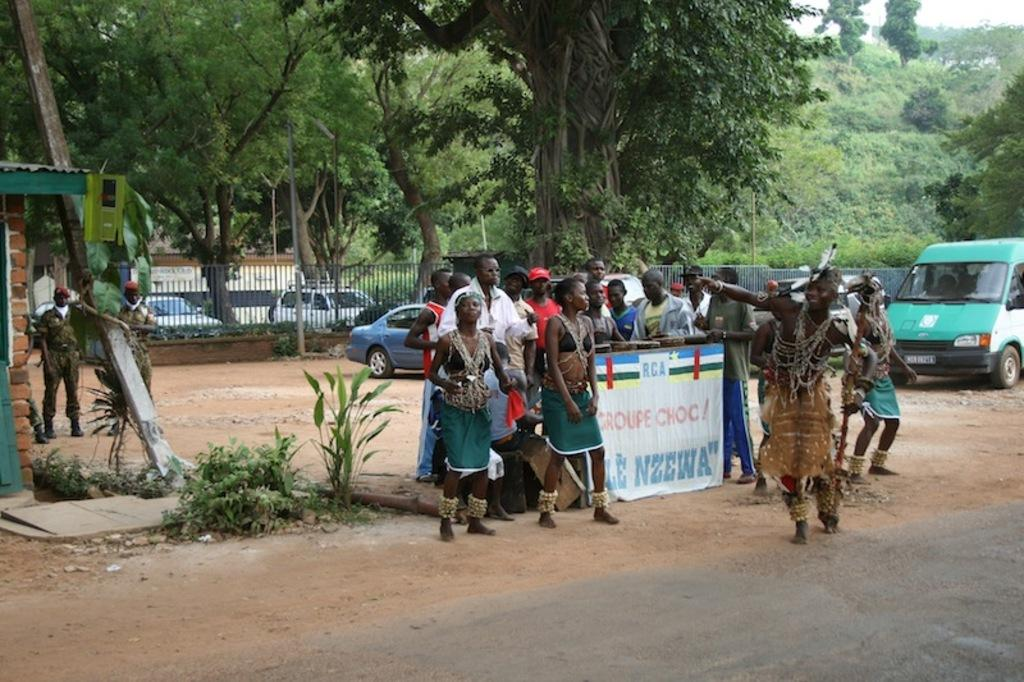What is the main subject of the image? The main subject of the image is a group of people standing. What type of natural elements can be seen in the image? There are trees, plants, and grass visible in the image. What type of man-made objects can be seen in the image? There are vehicles and a banner visible in the image. What part of the sky is visible in the image? The sky is visible in the top right corner of the image. What type of cloth is being used to whistle in the image? There is no cloth or whistling activity present in the image. How much salt is visible on the banner in the image? There is no salt present in the image, and the banner does not have any visible salt. 